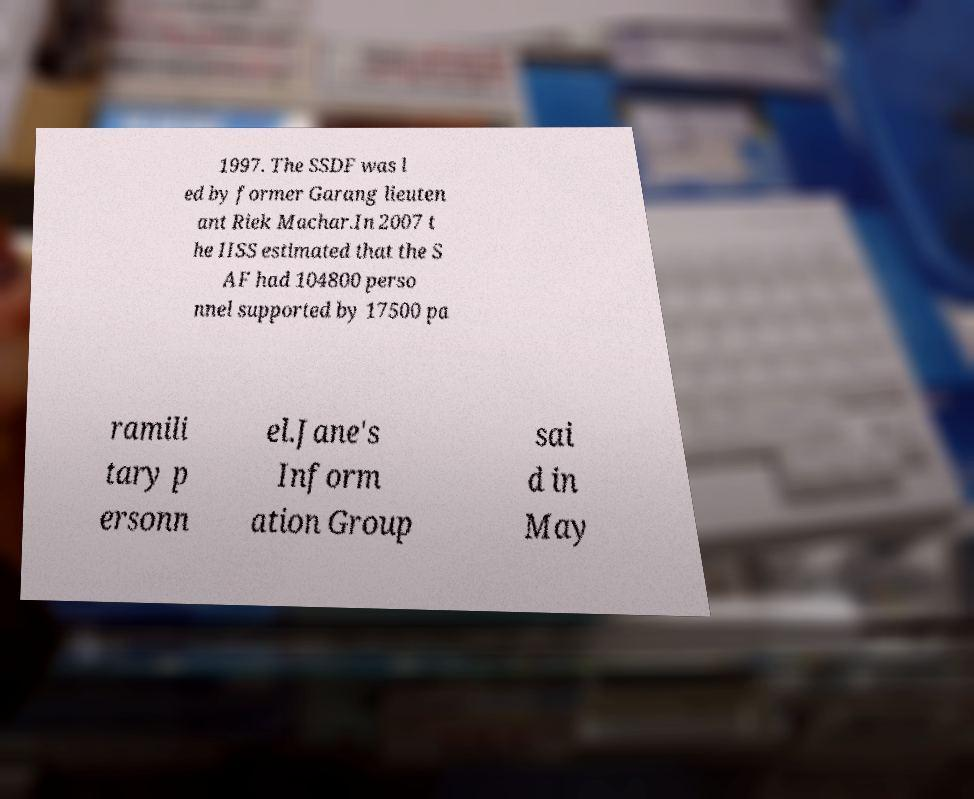I need the written content from this picture converted into text. Can you do that? 1997. The SSDF was l ed by former Garang lieuten ant Riek Machar.In 2007 t he IISS estimated that the S AF had 104800 perso nnel supported by 17500 pa ramili tary p ersonn el.Jane's Inform ation Group sai d in May 